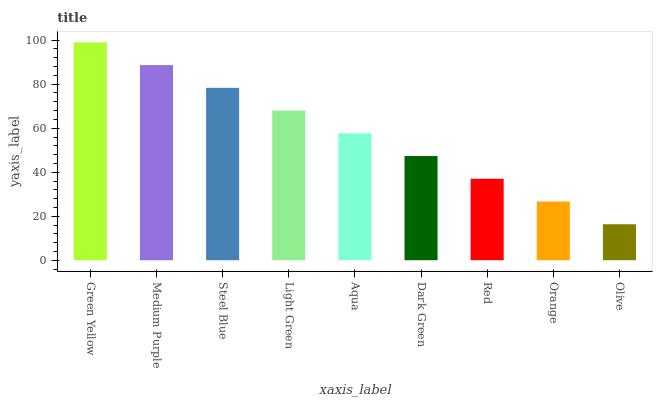Is Olive the minimum?
Answer yes or no. Yes. Is Green Yellow the maximum?
Answer yes or no. Yes. Is Medium Purple the minimum?
Answer yes or no. No. Is Medium Purple the maximum?
Answer yes or no. No. Is Green Yellow greater than Medium Purple?
Answer yes or no. Yes. Is Medium Purple less than Green Yellow?
Answer yes or no. Yes. Is Medium Purple greater than Green Yellow?
Answer yes or no. No. Is Green Yellow less than Medium Purple?
Answer yes or no. No. Is Aqua the high median?
Answer yes or no. Yes. Is Aqua the low median?
Answer yes or no. Yes. Is Olive the high median?
Answer yes or no. No. Is Light Green the low median?
Answer yes or no. No. 